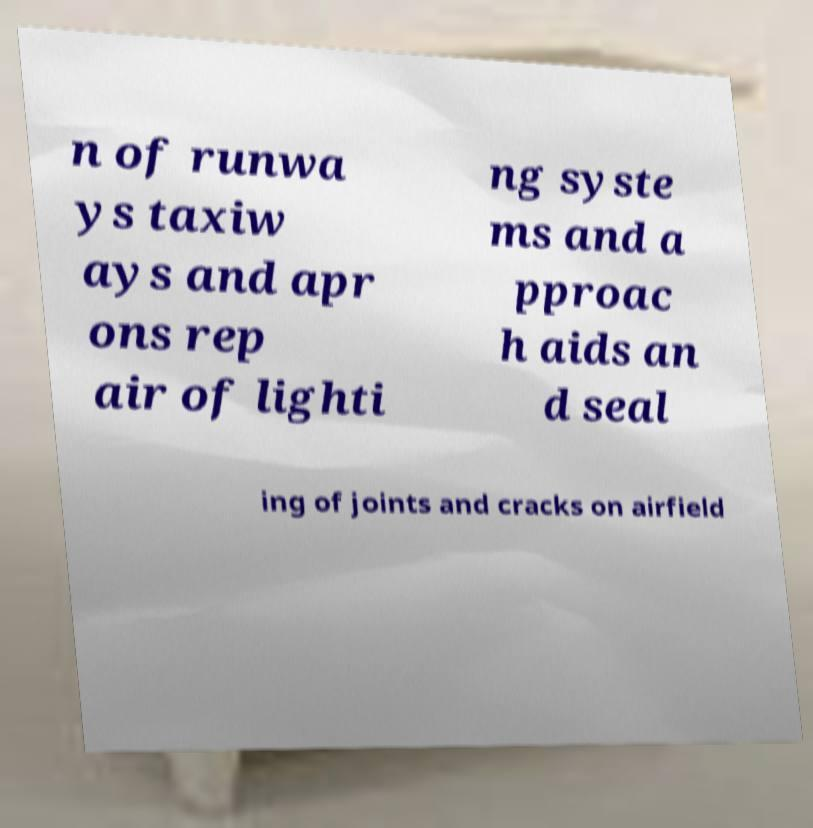Can you accurately transcribe the text from the provided image for me? n of runwa ys taxiw ays and apr ons rep air of lighti ng syste ms and a pproac h aids an d seal ing of joints and cracks on airfield 